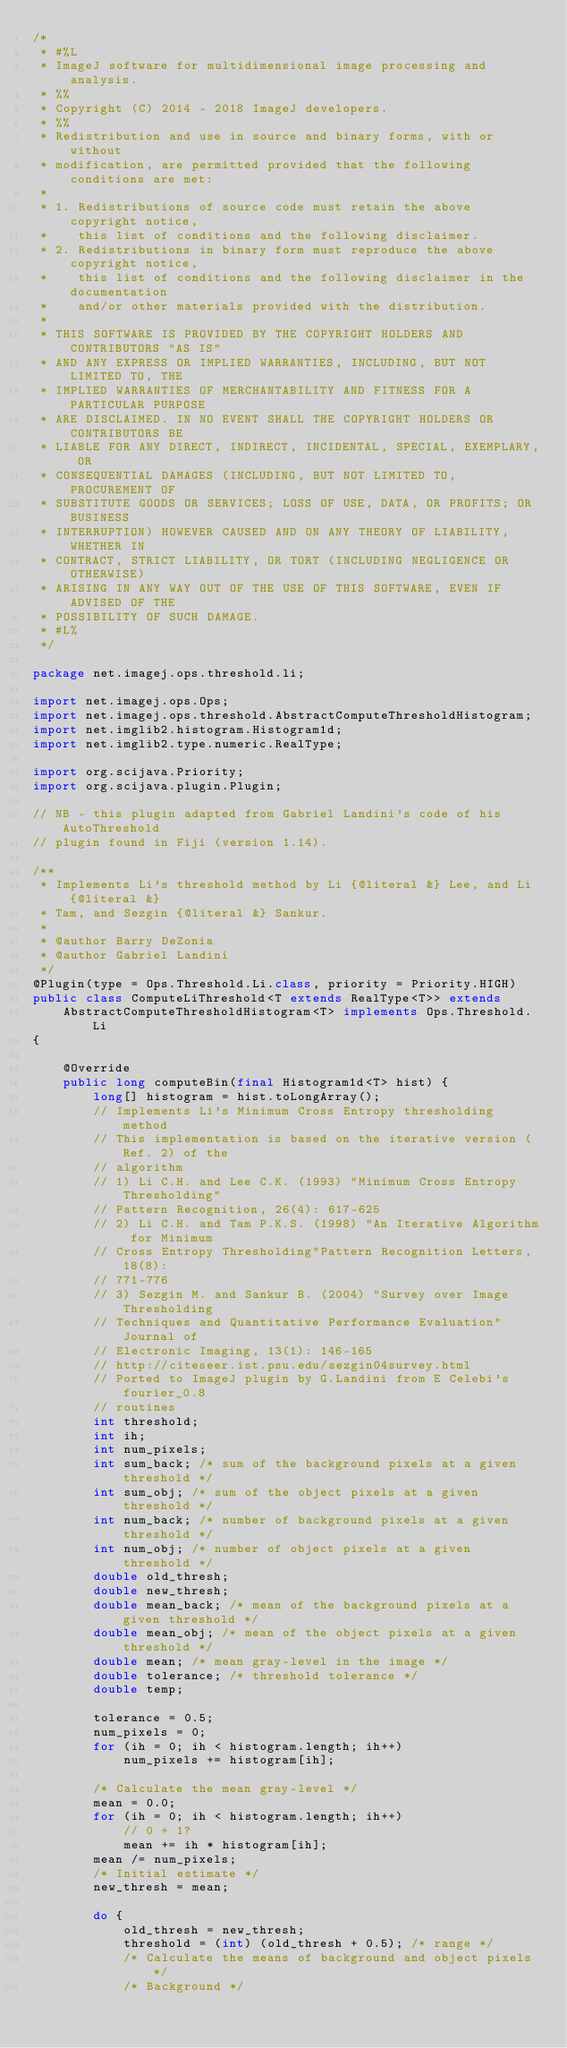<code> <loc_0><loc_0><loc_500><loc_500><_Java_>/*
 * #%L
 * ImageJ software for multidimensional image processing and analysis.
 * %%
 * Copyright (C) 2014 - 2018 ImageJ developers.
 * %%
 * Redistribution and use in source and binary forms, with or without
 * modification, are permitted provided that the following conditions are met:
 * 
 * 1. Redistributions of source code must retain the above copyright notice,
 *    this list of conditions and the following disclaimer.
 * 2. Redistributions in binary form must reproduce the above copyright notice,
 *    this list of conditions and the following disclaimer in the documentation
 *    and/or other materials provided with the distribution.
 * 
 * THIS SOFTWARE IS PROVIDED BY THE COPYRIGHT HOLDERS AND CONTRIBUTORS "AS IS"
 * AND ANY EXPRESS OR IMPLIED WARRANTIES, INCLUDING, BUT NOT LIMITED TO, THE
 * IMPLIED WARRANTIES OF MERCHANTABILITY AND FITNESS FOR A PARTICULAR PURPOSE
 * ARE DISCLAIMED. IN NO EVENT SHALL THE COPYRIGHT HOLDERS OR CONTRIBUTORS BE
 * LIABLE FOR ANY DIRECT, INDIRECT, INCIDENTAL, SPECIAL, EXEMPLARY, OR
 * CONSEQUENTIAL DAMAGES (INCLUDING, BUT NOT LIMITED TO, PROCUREMENT OF
 * SUBSTITUTE GOODS OR SERVICES; LOSS OF USE, DATA, OR PROFITS; OR BUSINESS
 * INTERRUPTION) HOWEVER CAUSED AND ON ANY THEORY OF LIABILITY, WHETHER IN
 * CONTRACT, STRICT LIABILITY, OR TORT (INCLUDING NEGLIGENCE OR OTHERWISE)
 * ARISING IN ANY WAY OUT OF THE USE OF THIS SOFTWARE, EVEN IF ADVISED OF THE
 * POSSIBILITY OF SUCH DAMAGE.
 * #L%
 */

package net.imagej.ops.threshold.li;

import net.imagej.ops.Ops;
import net.imagej.ops.threshold.AbstractComputeThresholdHistogram;
import net.imglib2.histogram.Histogram1d;
import net.imglib2.type.numeric.RealType;

import org.scijava.Priority;
import org.scijava.plugin.Plugin;

// NB - this plugin adapted from Gabriel Landini's code of his AutoThreshold
// plugin found in Fiji (version 1.14).

/**
 * Implements Li's threshold method by Li {@literal &} Lee, and Li {@literal &}
 * Tam, and Sezgin {@literal &} Sankur.
 * 
 * @author Barry DeZonia
 * @author Gabriel Landini
 */
@Plugin(type = Ops.Threshold.Li.class, priority = Priority.HIGH)
public class ComputeLiThreshold<T extends RealType<T>> extends
	AbstractComputeThresholdHistogram<T> implements Ops.Threshold.Li
{

	@Override
	public long computeBin(final Histogram1d<T> hist) {
		long[] histogram = hist.toLongArray();
		// Implements Li's Minimum Cross Entropy thresholding method
		// This implementation is based on the iterative version (Ref. 2) of the
		// algorithm
		// 1) Li C.H. and Lee C.K. (1993) "Minimum Cross Entropy Thresholding"
		// Pattern Recognition, 26(4): 617-625
		// 2) Li C.H. and Tam P.K.S. (1998) "An Iterative Algorithm for Minimum
		// Cross Entropy Thresholding"Pattern Recognition Letters, 18(8):
		// 771-776
		// 3) Sezgin M. and Sankur B. (2004) "Survey over Image Thresholding
		// Techniques and Quantitative Performance Evaluation" Journal of
		// Electronic Imaging, 13(1): 146-165
		// http://citeseer.ist.psu.edu/sezgin04survey.html
		// Ported to ImageJ plugin by G.Landini from E Celebi's fourier_0.8
		// routines
		int threshold;
		int ih;
		int num_pixels;
		int sum_back; /* sum of the background pixels at a given threshold */
		int sum_obj; /* sum of the object pixels at a given threshold */
		int num_back; /* number of background pixels at a given threshold */
		int num_obj; /* number of object pixels at a given threshold */
		double old_thresh;
		double new_thresh;
		double mean_back; /* mean of the background pixels at a given threshold */
		double mean_obj; /* mean of the object pixels at a given threshold */
		double mean; /* mean gray-level in the image */
		double tolerance; /* threshold tolerance */
		double temp;

		tolerance = 0.5;
		num_pixels = 0;
		for (ih = 0; ih < histogram.length; ih++)
			num_pixels += histogram[ih];

		/* Calculate the mean gray-level */
		mean = 0.0;
		for (ih = 0; ih < histogram.length; ih++)
			// 0 + 1?
			mean += ih * histogram[ih];
		mean /= num_pixels;
		/* Initial estimate */
		new_thresh = mean;

		do {
			old_thresh = new_thresh;
			threshold = (int) (old_thresh + 0.5); /* range */
			/* Calculate the means of background and object pixels */
			/* Background */</code> 